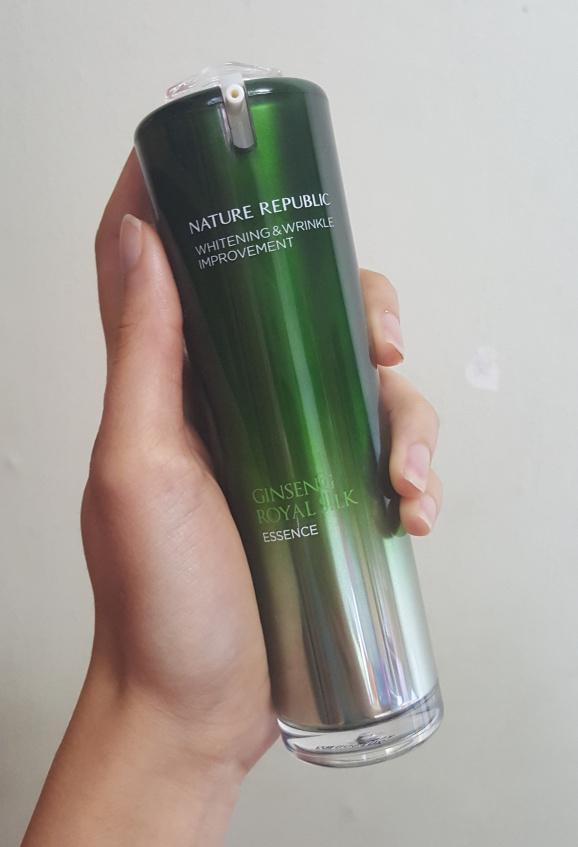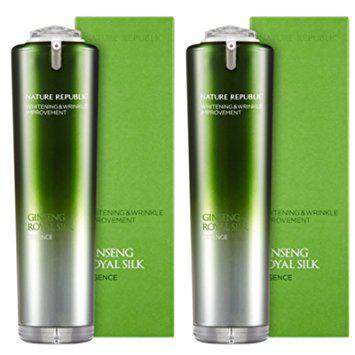The first image is the image on the left, the second image is the image on the right. Considering the images on both sides, is "The container in one of the images has a dark colored cap." valid? Answer yes or no. No. The first image is the image on the left, the second image is the image on the right. For the images shown, is this caption "The combined images include cylindrical bottles with green tops fading down to silver, upright green rectangular boxes, and no other products." true? Answer yes or no. Yes. 